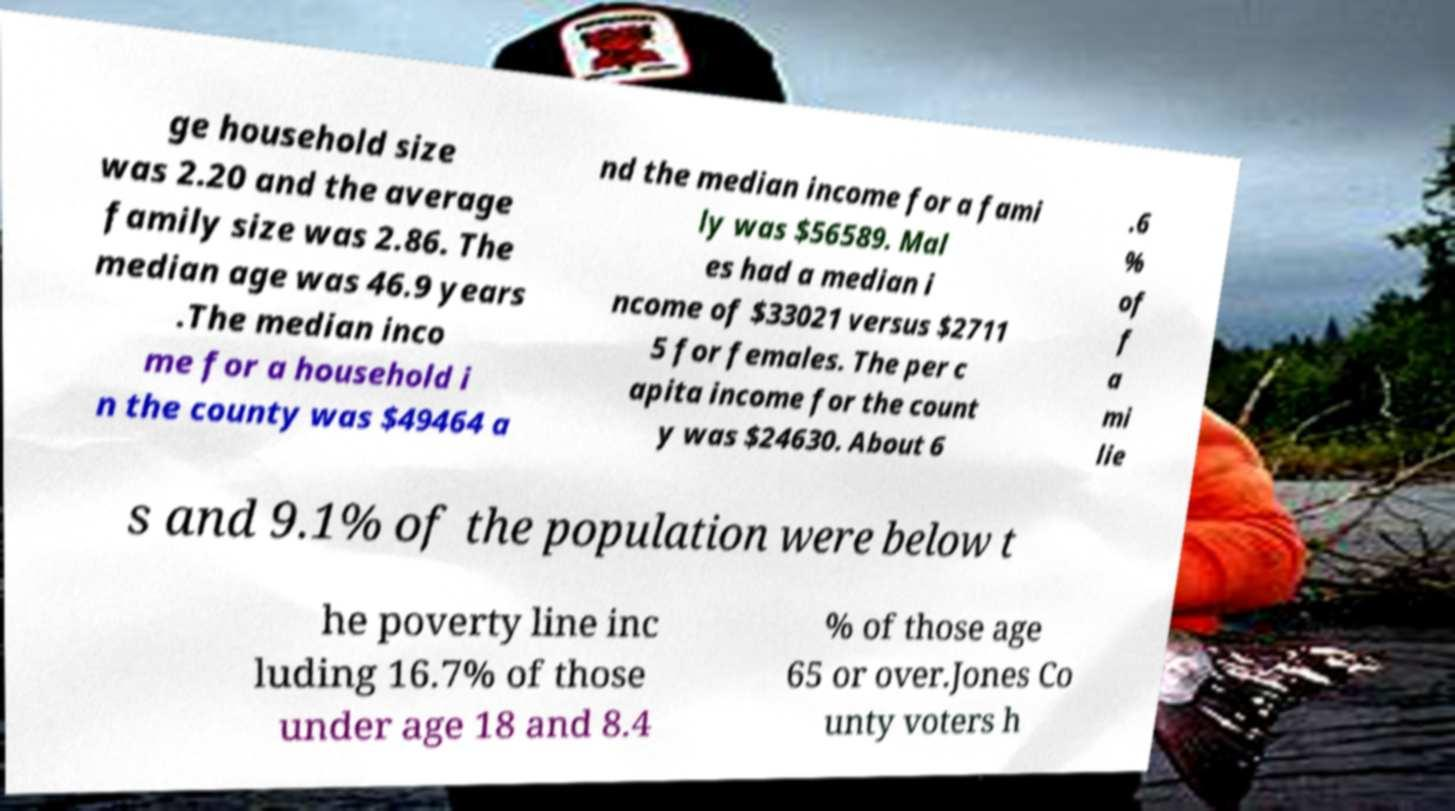Can you accurately transcribe the text from the provided image for me? ge household size was 2.20 and the average family size was 2.86. The median age was 46.9 years .The median inco me for a household i n the county was $49464 a nd the median income for a fami ly was $56589. Mal es had a median i ncome of $33021 versus $2711 5 for females. The per c apita income for the count y was $24630. About 6 .6 % of f a mi lie s and 9.1% of the population were below t he poverty line inc luding 16.7% of those under age 18 and 8.4 % of those age 65 or over.Jones Co unty voters h 